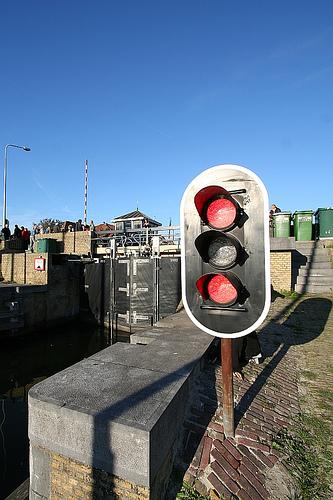Why is there a stop light?
Be succinct. Direct traffic. What does the channel lock fill with?
Keep it brief. Water. Is the middle light on?
Be succinct. No. What is this device for?
Concise answer only. Traffic. 